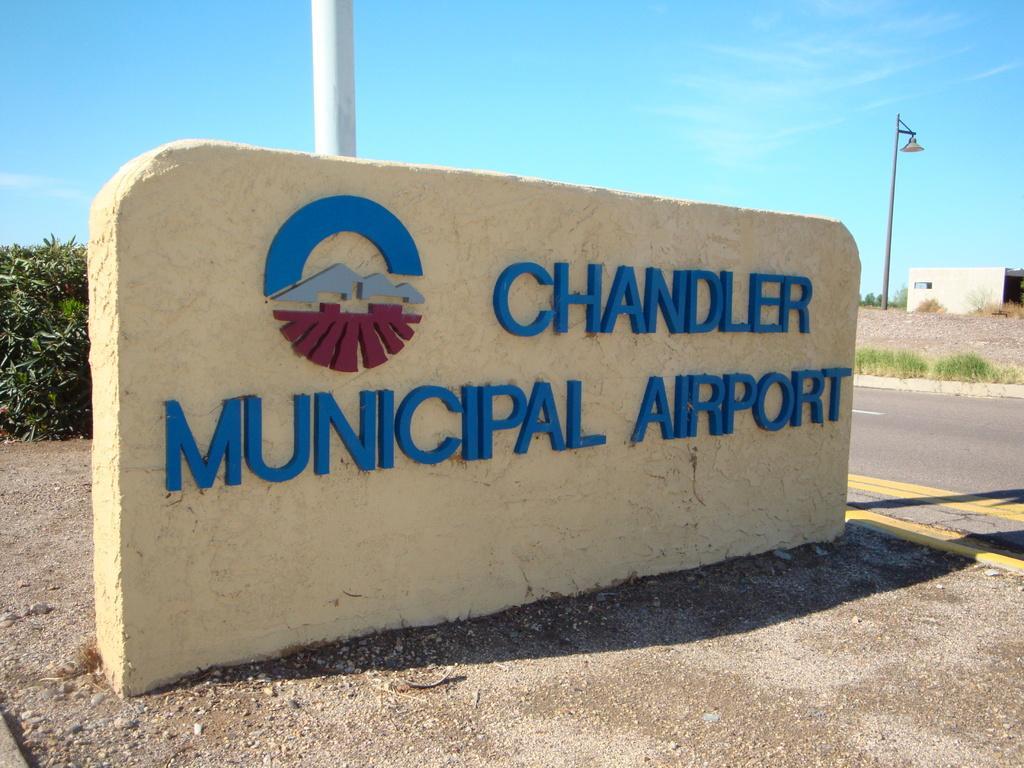Please provide a concise description of this image. Here we can see a logo and text written on a stone plate on the ground. In the background there are poles,plants on the left side,house on the right side and clouds in the sky. On the right we can see road and grass on the ground. 